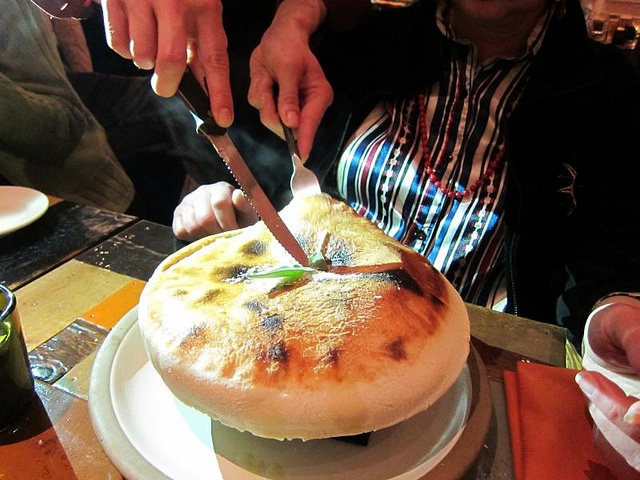Describe the objects in this image and their specific colors. I can see people in gray, black, white, maroon, and brown tones, dining table in gray, black, tan, and brown tones, people in gray, brown, and salmon tones, people in gray and black tones, and dining table in gray, maroon, and black tones in this image. 